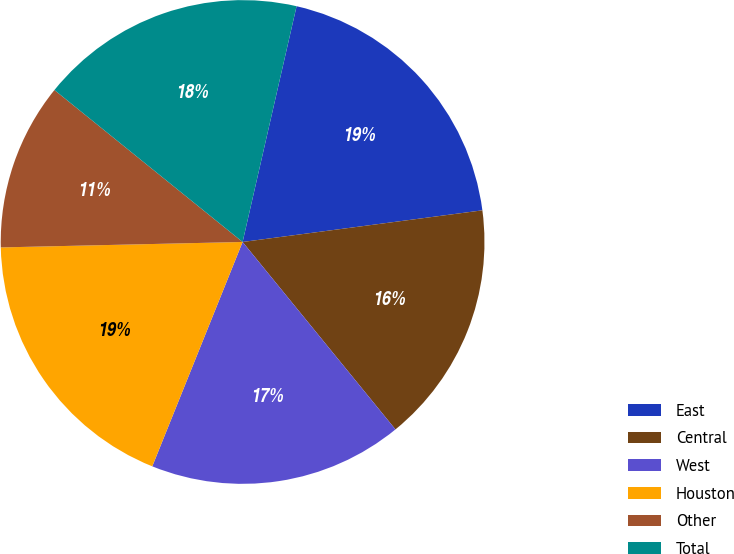<chart> <loc_0><loc_0><loc_500><loc_500><pie_chart><fcel>East<fcel>Central<fcel>West<fcel>Houston<fcel>Other<fcel>Total<nl><fcel>19.33%<fcel>16.2%<fcel>16.98%<fcel>18.55%<fcel>11.17%<fcel>17.77%<nl></chart> 